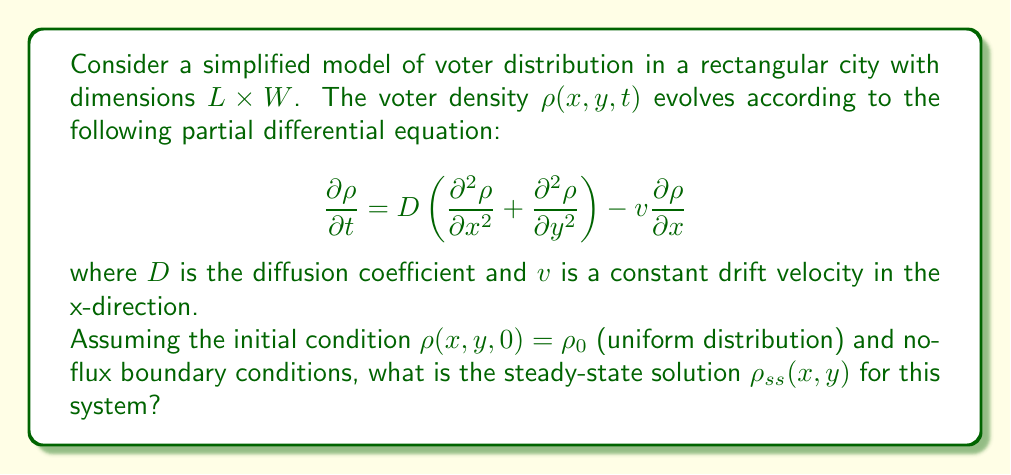Teach me how to tackle this problem. To solve this problem, we need to follow these steps:

1) For the steady-state solution, the time derivative is zero:

   $$\frac{\partial \rho}{\partial t} = 0$$

2) This reduces our PDE to:

   $$D\left(\frac{\partial^2 \rho}{\partial x^2} + \frac{\partial^2 \rho}{\partial y^2}\right) - v\frac{\partial \rho}{\partial x} = 0$$

3) Given the rectangular geometry and the drift in the x-direction, we can assume the solution has the form:

   $$\rho_{ss}(x,y) = f(x)$$

4) This simplifies our equation to an ODE:

   $$D\frac{d^2f}{dx^2} - v\frac{df}{dx} = 0$$

5) This is a second-order linear ODE with constant coefficients. The general solution is:

   $$f(x) = C_1 + C_2e^{\frac{v}{D}x}$$

6) To determine the constants, we use the no-flux boundary conditions:

   $$\left.\frac{df}{dx}\right|_{x=0} = \left.\frac{df}{dx}\right|_{x=L} = 0$$

7) Applying these conditions:

   At $x=0$: $C_2\frac{v}{D} = 0$, which implies $C_2 = 0$
   
   This leaves us with $f(x) = C_1$

8) To determine $C_1$, we use the conservation of total number of voters:

   $$\int_0^L\int_0^W \rho_{ss}(x,y) dydx = LW\rho_0$$

   This gives us $C_1 = \rho_0$

Therefore, the steady-state solution is a uniform distribution equal to the initial density.
Answer: The steady-state solution is $\rho_{ss}(x,y) = \rho_0$, where $\rho_0$ is the initial uniform density. 